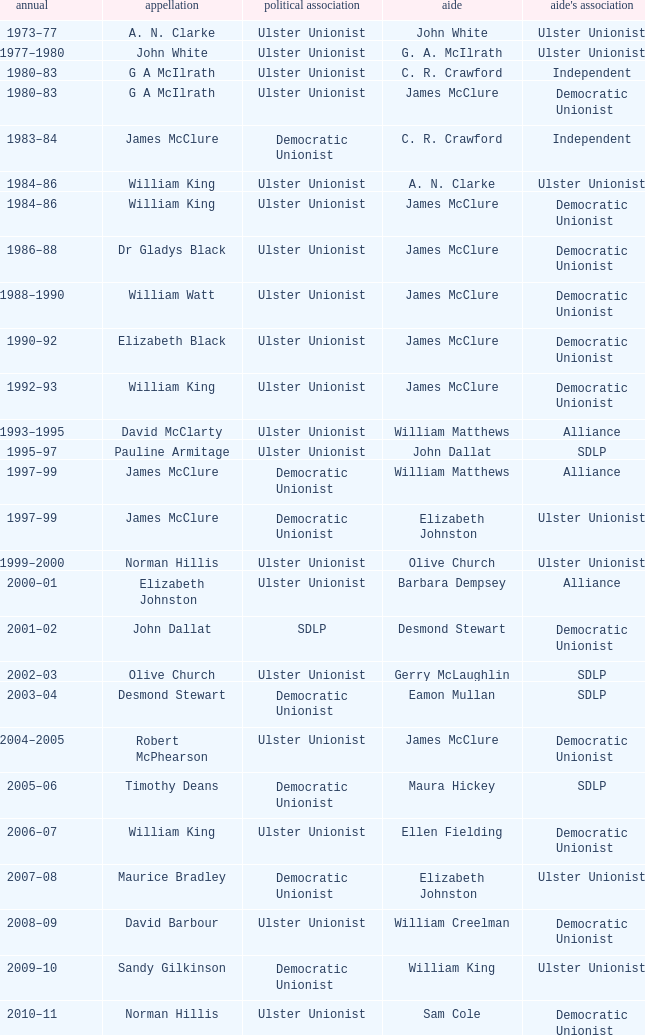What is the Name for 1997–99? James McClure, James McClure. 